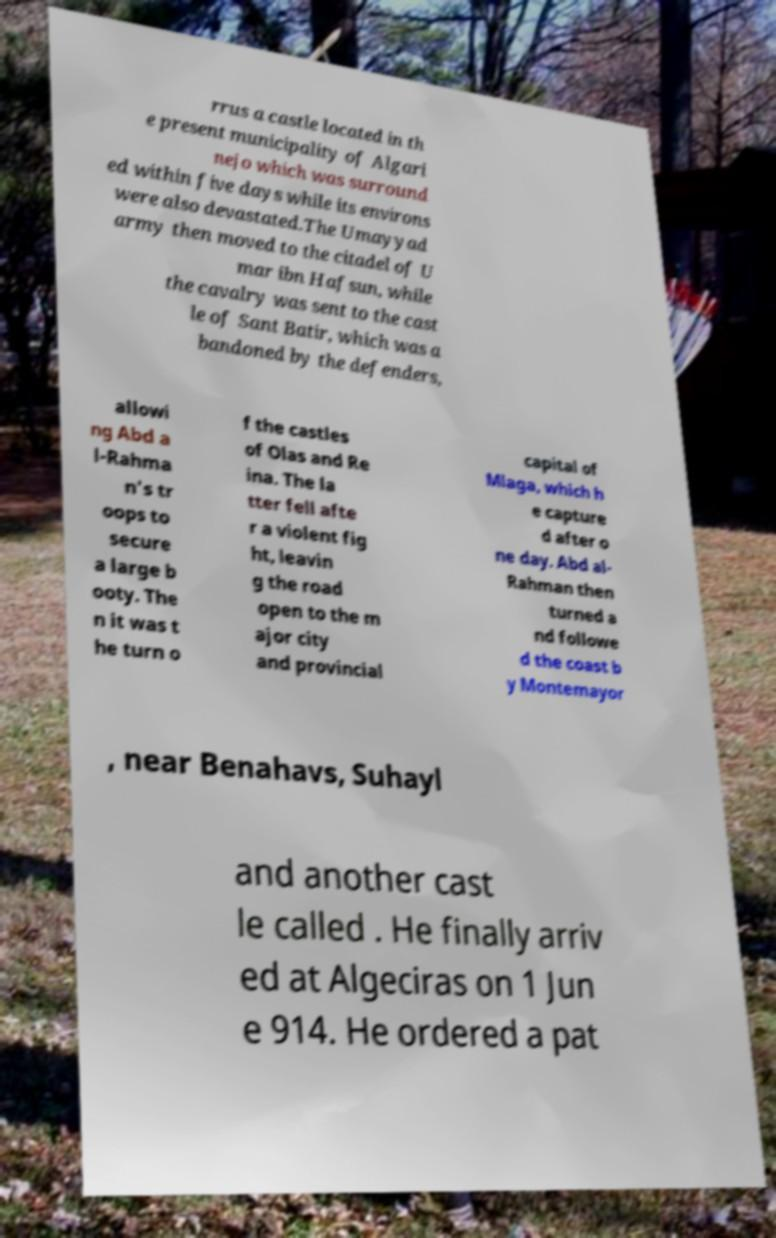Can you read and provide the text displayed in the image?This photo seems to have some interesting text. Can you extract and type it out for me? rrus a castle located in th e present municipality of Algari nejo which was surround ed within five days while its environs were also devastated.The Umayyad army then moved to the citadel of U mar ibn Hafsun, while the cavalry was sent to the cast le of Sant Batir, which was a bandoned by the defenders, allowi ng Abd a l-Rahma n's tr oops to secure a large b ooty. The n it was t he turn o f the castles of Olas and Re ina. The la tter fell afte r a violent fig ht, leavin g the road open to the m ajor city and provincial capital of Mlaga, which h e capture d after o ne day. Abd al- Rahman then turned a nd followe d the coast b y Montemayor , near Benahavs, Suhayl and another cast le called . He finally arriv ed at Algeciras on 1 Jun e 914. He ordered a pat 